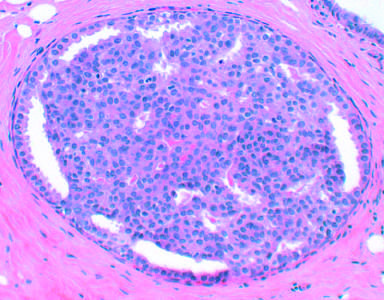s predominance of blastemal morphology and diffuse anaplasia characterized by increased numbers of epithelial cells, as in this example of epithelial hyperplasia?
Answer the question using a single word or phrase. No 